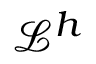Convert formula to latex. <formula><loc_0><loc_0><loc_500><loc_500>\mathcal { L } ^ { h }</formula> 